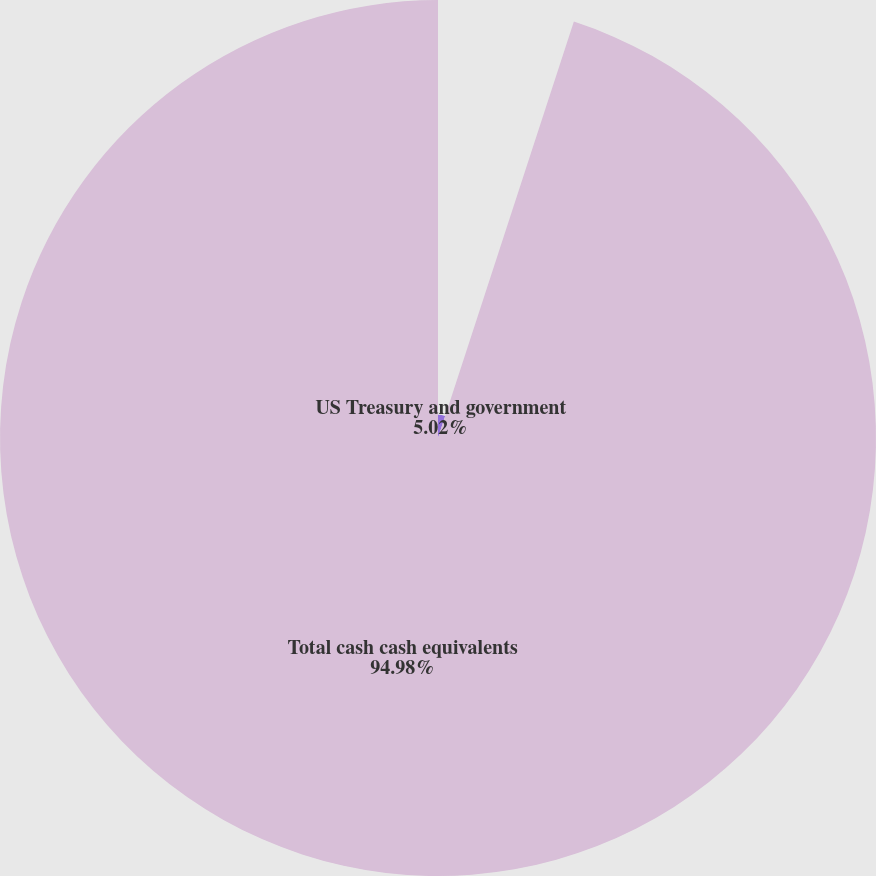<chart> <loc_0><loc_0><loc_500><loc_500><pie_chart><fcel>US Treasury and government<fcel>Total cash cash equivalents<nl><fcel>5.02%<fcel>94.98%<nl></chart> 